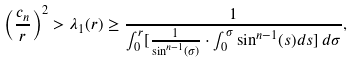Convert formula to latex. <formula><loc_0><loc_0><loc_500><loc_500>\left ( \frac { c _ { n } } { r } \right ) ^ { 2 } > \lambda _ { 1 } ( r ) \geq \frac { 1 } { \int _ { 0 } ^ { r } [ \frac { 1 } { \sin ^ { n - 1 } ( \sigma ) } \cdot \int _ { 0 } ^ { \sigma } \sin ^ { n - 1 } ( s ) d s ] \, d \sigma } ,</formula> 